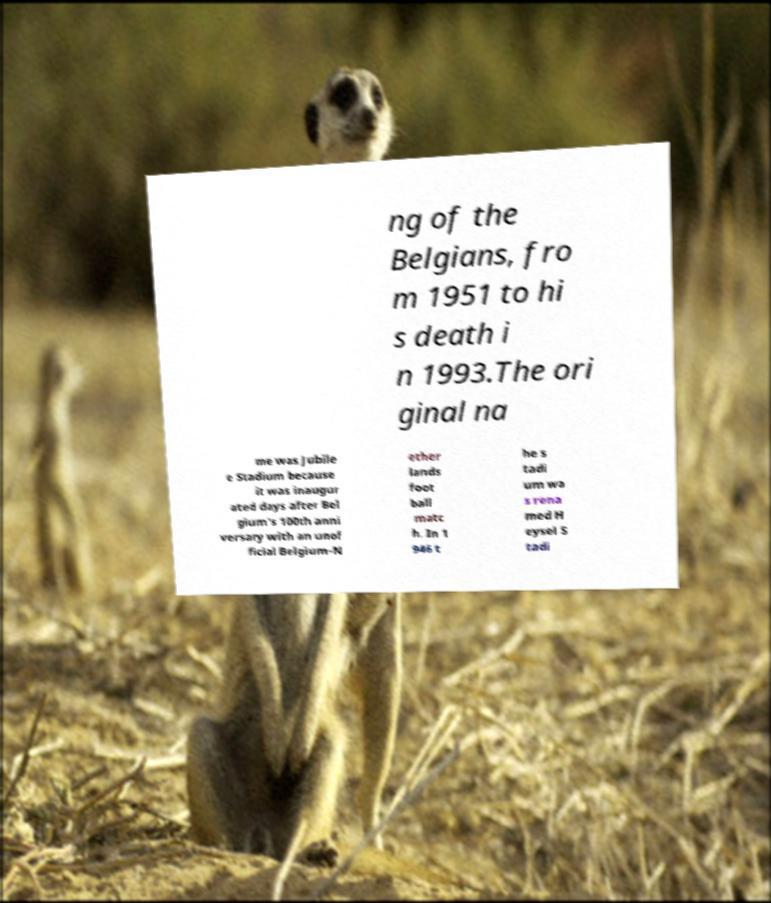Could you assist in decoding the text presented in this image and type it out clearly? ng of the Belgians, fro m 1951 to hi s death i n 1993.The ori ginal na me was Jubile e Stadium because it was inaugur ated days after Bel gium's 100th anni versary with an unof ficial Belgium-N ether lands foot ball matc h. In 1 946 t he s tadi um wa s rena med H eysel S tadi 